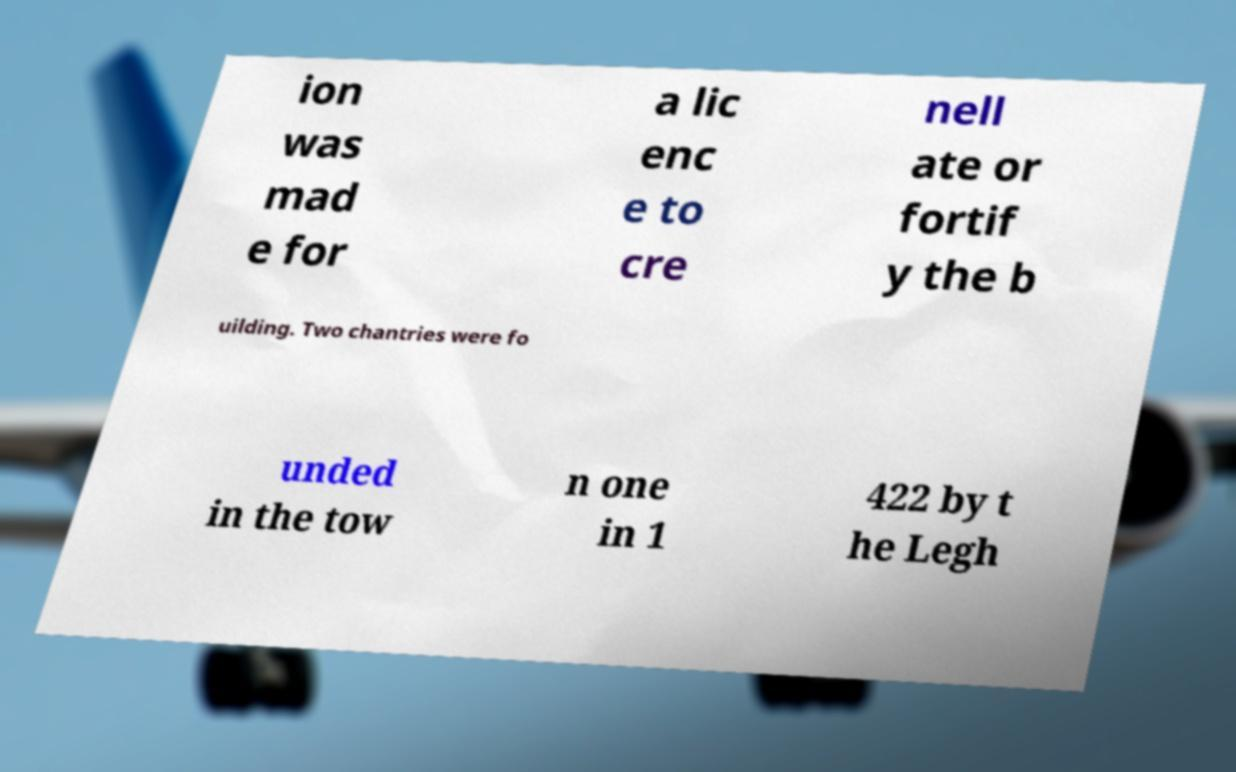For documentation purposes, I need the text within this image transcribed. Could you provide that? ion was mad e for a lic enc e to cre nell ate or fortif y the b uilding. Two chantries were fo unded in the tow n one in 1 422 by t he Legh 